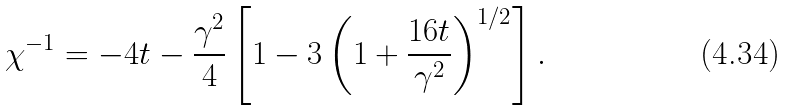Convert formula to latex. <formula><loc_0><loc_0><loc_500><loc_500>\chi ^ { - 1 } = - 4 t - \frac { \gamma ^ { 2 } } { 4 } \left [ 1 - 3 \left ( 1 + \frac { 1 6 t } { \gamma ^ { 2 } } \right ) ^ { 1 / 2 } \right ] .</formula> 